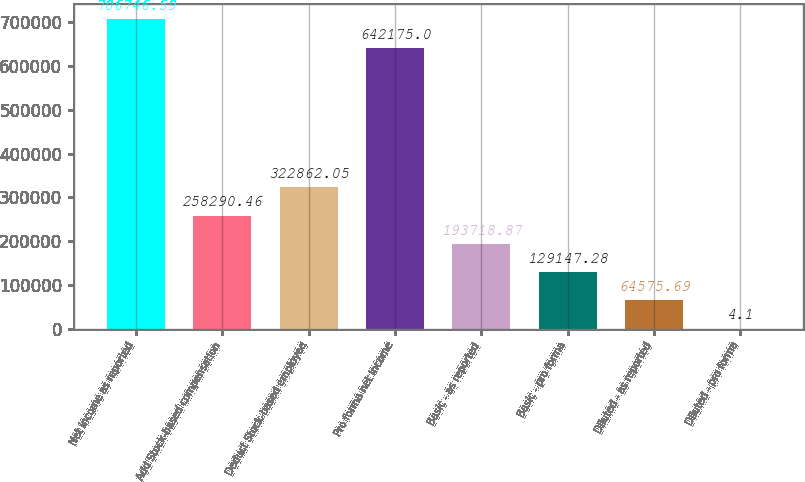<chart> <loc_0><loc_0><loc_500><loc_500><bar_chart><fcel>Net income as reported<fcel>Add Stock-based compensation<fcel>Deduct Stock-based employee<fcel>Pro forma net income<fcel>Basic - as reported<fcel>Basic - pro forma<fcel>Diluted - as reported<fcel>Diluted - pro forma<nl><fcel>706747<fcel>258290<fcel>322862<fcel>642175<fcel>193719<fcel>129147<fcel>64575.7<fcel>4.1<nl></chart> 